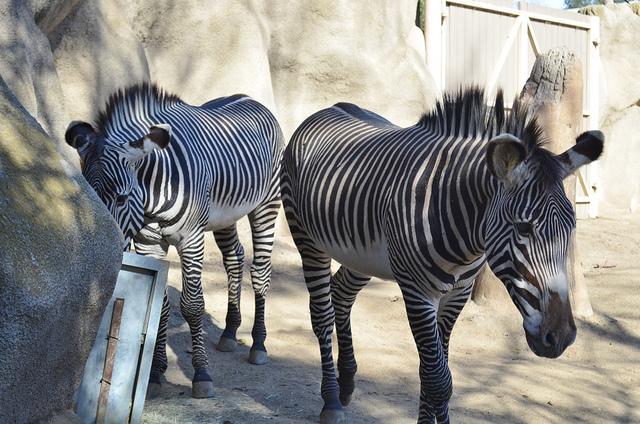Are the zebras eating?
Give a very brief answer. No. Are the zebras being protected?
Concise answer only. Yes. How many zebras?
Write a very short answer. 2. 